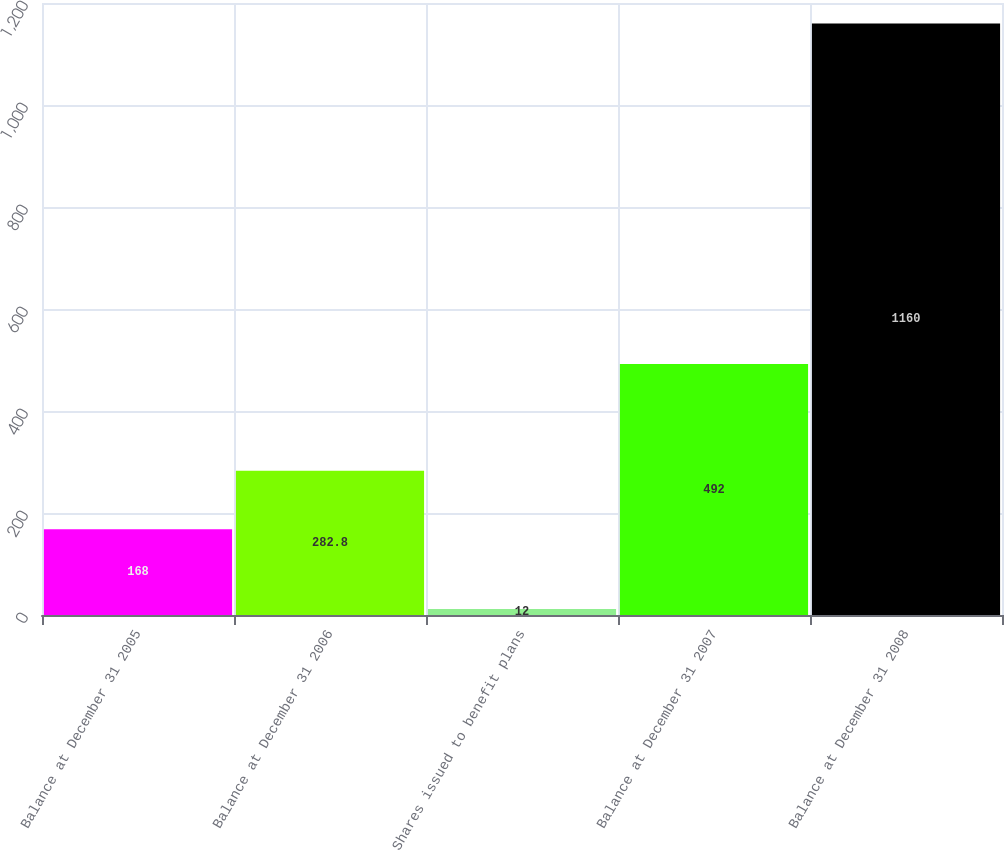<chart> <loc_0><loc_0><loc_500><loc_500><bar_chart><fcel>Balance at December 31 2005<fcel>Balance at December 31 2006<fcel>Shares issued to benefit plans<fcel>Balance at December 31 2007<fcel>Balance at December 31 2008<nl><fcel>168<fcel>282.8<fcel>12<fcel>492<fcel>1160<nl></chart> 